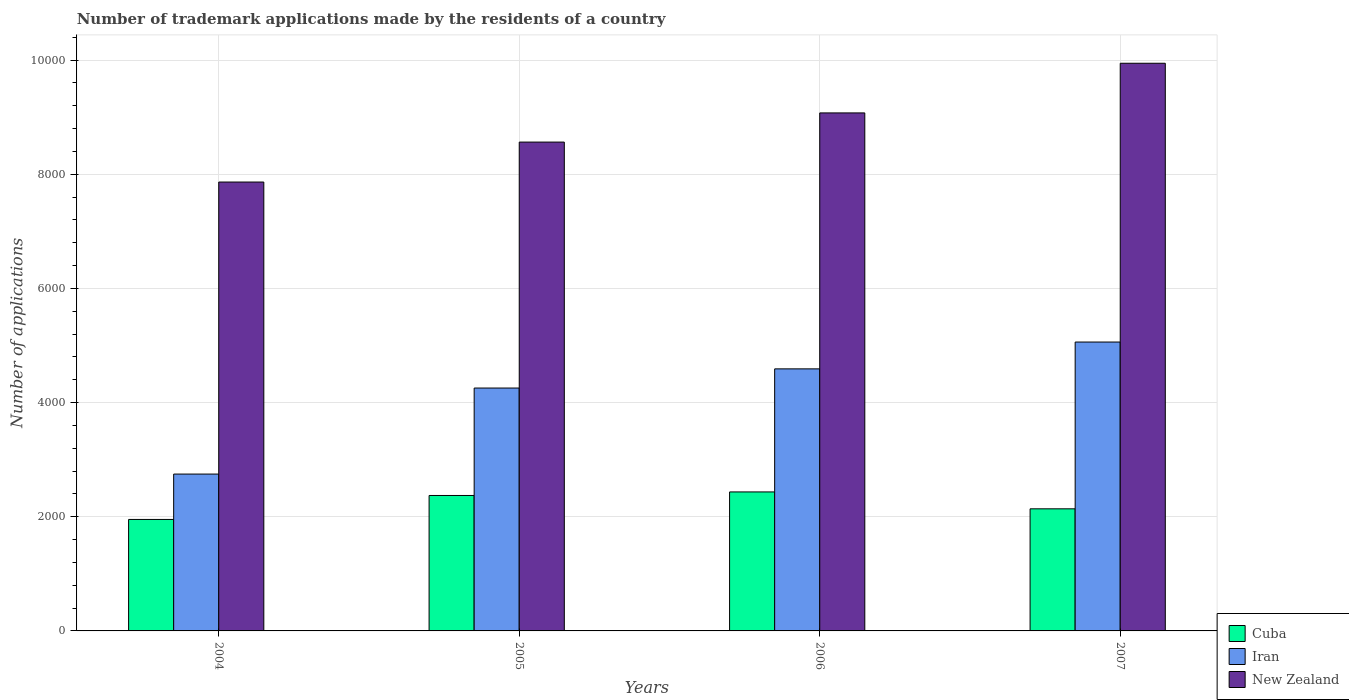How many different coloured bars are there?
Your answer should be very brief. 3. How many bars are there on the 2nd tick from the left?
Your answer should be compact. 3. How many bars are there on the 3rd tick from the right?
Provide a short and direct response. 3. What is the label of the 4th group of bars from the left?
Ensure brevity in your answer.  2007. What is the number of trademark applications made by the residents in Iran in 2006?
Provide a short and direct response. 4591. Across all years, what is the maximum number of trademark applications made by the residents in New Zealand?
Offer a terse response. 9945. Across all years, what is the minimum number of trademark applications made by the residents in New Zealand?
Offer a very short reply. 7864. In which year was the number of trademark applications made by the residents in New Zealand maximum?
Provide a succinct answer. 2007. What is the total number of trademark applications made by the residents in New Zealand in the graph?
Offer a very short reply. 3.54e+04. What is the difference between the number of trademark applications made by the residents in New Zealand in 2004 and that in 2005?
Ensure brevity in your answer.  -700. What is the difference between the number of trademark applications made by the residents in New Zealand in 2007 and the number of trademark applications made by the residents in Cuba in 2006?
Your answer should be very brief. 7510. What is the average number of trademark applications made by the residents in Iran per year?
Your answer should be very brief. 4163.75. In the year 2007, what is the difference between the number of trademark applications made by the residents in New Zealand and number of trademark applications made by the residents in Cuba?
Ensure brevity in your answer.  7806. In how many years, is the number of trademark applications made by the residents in New Zealand greater than 4800?
Offer a terse response. 4. What is the ratio of the number of trademark applications made by the residents in Cuba in 2005 to that in 2007?
Offer a very short reply. 1.11. Is the difference between the number of trademark applications made by the residents in New Zealand in 2005 and 2006 greater than the difference between the number of trademark applications made by the residents in Cuba in 2005 and 2006?
Your answer should be very brief. No. What is the difference between the highest and the second highest number of trademark applications made by the residents in Iran?
Your answer should be compact. 470. What is the difference between the highest and the lowest number of trademark applications made by the residents in Iran?
Keep it short and to the point. 2313. In how many years, is the number of trademark applications made by the residents in Cuba greater than the average number of trademark applications made by the residents in Cuba taken over all years?
Your answer should be very brief. 2. What does the 1st bar from the left in 2004 represents?
Offer a very short reply. Cuba. What does the 3rd bar from the right in 2007 represents?
Your response must be concise. Cuba. How many bars are there?
Provide a succinct answer. 12. Are all the bars in the graph horizontal?
Offer a very short reply. No. Are the values on the major ticks of Y-axis written in scientific E-notation?
Keep it short and to the point. No. Does the graph contain any zero values?
Provide a succinct answer. No. Does the graph contain grids?
Ensure brevity in your answer.  Yes. What is the title of the graph?
Your answer should be compact. Number of trademark applications made by the residents of a country. Does "Bosnia and Herzegovina" appear as one of the legend labels in the graph?
Give a very brief answer. No. What is the label or title of the X-axis?
Keep it short and to the point. Years. What is the label or title of the Y-axis?
Your answer should be very brief. Number of applications. What is the Number of applications in Cuba in 2004?
Your response must be concise. 1953. What is the Number of applications of Iran in 2004?
Make the answer very short. 2748. What is the Number of applications in New Zealand in 2004?
Ensure brevity in your answer.  7864. What is the Number of applications in Cuba in 2005?
Your answer should be compact. 2373. What is the Number of applications of Iran in 2005?
Your answer should be very brief. 4255. What is the Number of applications of New Zealand in 2005?
Offer a very short reply. 8564. What is the Number of applications in Cuba in 2006?
Offer a terse response. 2435. What is the Number of applications in Iran in 2006?
Ensure brevity in your answer.  4591. What is the Number of applications of New Zealand in 2006?
Make the answer very short. 9075. What is the Number of applications in Cuba in 2007?
Give a very brief answer. 2139. What is the Number of applications of Iran in 2007?
Your response must be concise. 5061. What is the Number of applications in New Zealand in 2007?
Your answer should be very brief. 9945. Across all years, what is the maximum Number of applications in Cuba?
Offer a terse response. 2435. Across all years, what is the maximum Number of applications of Iran?
Make the answer very short. 5061. Across all years, what is the maximum Number of applications of New Zealand?
Your answer should be very brief. 9945. Across all years, what is the minimum Number of applications in Cuba?
Give a very brief answer. 1953. Across all years, what is the minimum Number of applications in Iran?
Provide a succinct answer. 2748. Across all years, what is the minimum Number of applications in New Zealand?
Your answer should be very brief. 7864. What is the total Number of applications of Cuba in the graph?
Keep it short and to the point. 8900. What is the total Number of applications in Iran in the graph?
Make the answer very short. 1.67e+04. What is the total Number of applications of New Zealand in the graph?
Make the answer very short. 3.54e+04. What is the difference between the Number of applications of Cuba in 2004 and that in 2005?
Provide a succinct answer. -420. What is the difference between the Number of applications of Iran in 2004 and that in 2005?
Offer a terse response. -1507. What is the difference between the Number of applications in New Zealand in 2004 and that in 2005?
Your response must be concise. -700. What is the difference between the Number of applications in Cuba in 2004 and that in 2006?
Your response must be concise. -482. What is the difference between the Number of applications of Iran in 2004 and that in 2006?
Make the answer very short. -1843. What is the difference between the Number of applications in New Zealand in 2004 and that in 2006?
Keep it short and to the point. -1211. What is the difference between the Number of applications in Cuba in 2004 and that in 2007?
Offer a very short reply. -186. What is the difference between the Number of applications of Iran in 2004 and that in 2007?
Your response must be concise. -2313. What is the difference between the Number of applications in New Zealand in 2004 and that in 2007?
Ensure brevity in your answer.  -2081. What is the difference between the Number of applications of Cuba in 2005 and that in 2006?
Keep it short and to the point. -62. What is the difference between the Number of applications of Iran in 2005 and that in 2006?
Offer a terse response. -336. What is the difference between the Number of applications of New Zealand in 2005 and that in 2006?
Keep it short and to the point. -511. What is the difference between the Number of applications of Cuba in 2005 and that in 2007?
Offer a very short reply. 234. What is the difference between the Number of applications of Iran in 2005 and that in 2007?
Make the answer very short. -806. What is the difference between the Number of applications in New Zealand in 2005 and that in 2007?
Your answer should be very brief. -1381. What is the difference between the Number of applications of Cuba in 2006 and that in 2007?
Offer a terse response. 296. What is the difference between the Number of applications in Iran in 2006 and that in 2007?
Offer a very short reply. -470. What is the difference between the Number of applications of New Zealand in 2006 and that in 2007?
Your response must be concise. -870. What is the difference between the Number of applications in Cuba in 2004 and the Number of applications in Iran in 2005?
Your response must be concise. -2302. What is the difference between the Number of applications of Cuba in 2004 and the Number of applications of New Zealand in 2005?
Keep it short and to the point. -6611. What is the difference between the Number of applications of Iran in 2004 and the Number of applications of New Zealand in 2005?
Give a very brief answer. -5816. What is the difference between the Number of applications in Cuba in 2004 and the Number of applications in Iran in 2006?
Make the answer very short. -2638. What is the difference between the Number of applications in Cuba in 2004 and the Number of applications in New Zealand in 2006?
Provide a succinct answer. -7122. What is the difference between the Number of applications in Iran in 2004 and the Number of applications in New Zealand in 2006?
Give a very brief answer. -6327. What is the difference between the Number of applications in Cuba in 2004 and the Number of applications in Iran in 2007?
Your answer should be compact. -3108. What is the difference between the Number of applications of Cuba in 2004 and the Number of applications of New Zealand in 2007?
Offer a terse response. -7992. What is the difference between the Number of applications in Iran in 2004 and the Number of applications in New Zealand in 2007?
Provide a succinct answer. -7197. What is the difference between the Number of applications in Cuba in 2005 and the Number of applications in Iran in 2006?
Offer a very short reply. -2218. What is the difference between the Number of applications in Cuba in 2005 and the Number of applications in New Zealand in 2006?
Make the answer very short. -6702. What is the difference between the Number of applications of Iran in 2005 and the Number of applications of New Zealand in 2006?
Provide a short and direct response. -4820. What is the difference between the Number of applications in Cuba in 2005 and the Number of applications in Iran in 2007?
Your response must be concise. -2688. What is the difference between the Number of applications of Cuba in 2005 and the Number of applications of New Zealand in 2007?
Ensure brevity in your answer.  -7572. What is the difference between the Number of applications of Iran in 2005 and the Number of applications of New Zealand in 2007?
Offer a very short reply. -5690. What is the difference between the Number of applications of Cuba in 2006 and the Number of applications of Iran in 2007?
Make the answer very short. -2626. What is the difference between the Number of applications in Cuba in 2006 and the Number of applications in New Zealand in 2007?
Provide a short and direct response. -7510. What is the difference between the Number of applications in Iran in 2006 and the Number of applications in New Zealand in 2007?
Offer a very short reply. -5354. What is the average Number of applications in Cuba per year?
Keep it short and to the point. 2225. What is the average Number of applications of Iran per year?
Offer a very short reply. 4163.75. What is the average Number of applications in New Zealand per year?
Provide a short and direct response. 8862. In the year 2004, what is the difference between the Number of applications in Cuba and Number of applications in Iran?
Offer a terse response. -795. In the year 2004, what is the difference between the Number of applications in Cuba and Number of applications in New Zealand?
Your response must be concise. -5911. In the year 2004, what is the difference between the Number of applications of Iran and Number of applications of New Zealand?
Give a very brief answer. -5116. In the year 2005, what is the difference between the Number of applications in Cuba and Number of applications in Iran?
Provide a short and direct response. -1882. In the year 2005, what is the difference between the Number of applications in Cuba and Number of applications in New Zealand?
Make the answer very short. -6191. In the year 2005, what is the difference between the Number of applications of Iran and Number of applications of New Zealand?
Ensure brevity in your answer.  -4309. In the year 2006, what is the difference between the Number of applications of Cuba and Number of applications of Iran?
Provide a short and direct response. -2156. In the year 2006, what is the difference between the Number of applications in Cuba and Number of applications in New Zealand?
Your response must be concise. -6640. In the year 2006, what is the difference between the Number of applications in Iran and Number of applications in New Zealand?
Your answer should be very brief. -4484. In the year 2007, what is the difference between the Number of applications of Cuba and Number of applications of Iran?
Your answer should be very brief. -2922. In the year 2007, what is the difference between the Number of applications of Cuba and Number of applications of New Zealand?
Make the answer very short. -7806. In the year 2007, what is the difference between the Number of applications of Iran and Number of applications of New Zealand?
Your answer should be very brief. -4884. What is the ratio of the Number of applications in Cuba in 2004 to that in 2005?
Provide a short and direct response. 0.82. What is the ratio of the Number of applications in Iran in 2004 to that in 2005?
Offer a terse response. 0.65. What is the ratio of the Number of applications of New Zealand in 2004 to that in 2005?
Give a very brief answer. 0.92. What is the ratio of the Number of applications in Cuba in 2004 to that in 2006?
Your response must be concise. 0.8. What is the ratio of the Number of applications of Iran in 2004 to that in 2006?
Offer a terse response. 0.6. What is the ratio of the Number of applications in New Zealand in 2004 to that in 2006?
Offer a terse response. 0.87. What is the ratio of the Number of applications in Cuba in 2004 to that in 2007?
Your answer should be compact. 0.91. What is the ratio of the Number of applications in Iran in 2004 to that in 2007?
Offer a very short reply. 0.54. What is the ratio of the Number of applications in New Zealand in 2004 to that in 2007?
Ensure brevity in your answer.  0.79. What is the ratio of the Number of applications of Cuba in 2005 to that in 2006?
Provide a short and direct response. 0.97. What is the ratio of the Number of applications in Iran in 2005 to that in 2006?
Your answer should be very brief. 0.93. What is the ratio of the Number of applications in New Zealand in 2005 to that in 2006?
Ensure brevity in your answer.  0.94. What is the ratio of the Number of applications in Cuba in 2005 to that in 2007?
Offer a very short reply. 1.11. What is the ratio of the Number of applications of Iran in 2005 to that in 2007?
Give a very brief answer. 0.84. What is the ratio of the Number of applications in New Zealand in 2005 to that in 2007?
Provide a succinct answer. 0.86. What is the ratio of the Number of applications of Cuba in 2006 to that in 2007?
Offer a very short reply. 1.14. What is the ratio of the Number of applications in Iran in 2006 to that in 2007?
Ensure brevity in your answer.  0.91. What is the ratio of the Number of applications in New Zealand in 2006 to that in 2007?
Make the answer very short. 0.91. What is the difference between the highest and the second highest Number of applications in Iran?
Offer a very short reply. 470. What is the difference between the highest and the second highest Number of applications in New Zealand?
Your answer should be compact. 870. What is the difference between the highest and the lowest Number of applications in Cuba?
Provide a short and direct response. 482. What is the difference between the highest and the lowest Number of applications of Iran?
Provide a short and direct response. 2313. What is the difference between the highest and the lowest Number of applications in New Zealand?
Keep it short and to the point. 2081. 